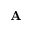<formula> <loc_0><loc_0><loc_500><loc_500>{ A }</formula> 